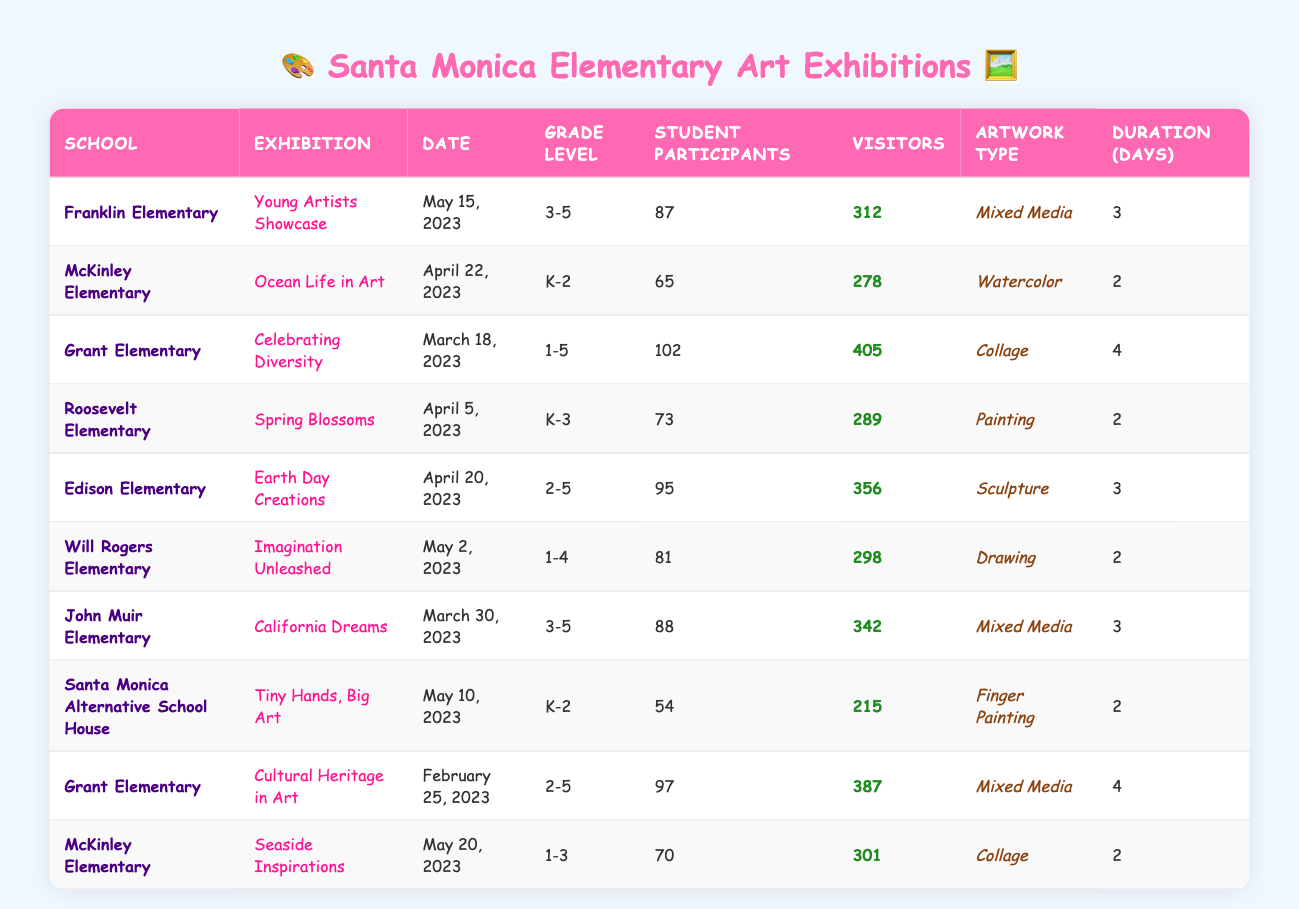What is the highest visitor count for an exhibition? The visitor counts for the exhibitions are: 312, 278, 405, 289, 356, 298, 342, 215, 387, and 301. Among these, 405 is the highest count, which corresponds to the exhibition "Celebrating Diversity" at Grant Elementary.
Answer: 405 Which school had the largest number of student participants? The number of student participants for each school are: Franklin (87), McKinley (65), Grant (102), Roosevelt (73), Edison (95), Will Rogers (81), John Muir (88), Santa Monica Alternative (54), Grant (97), and McKinley (70). The largest number is 102 from Grant Elementary during the "Celebrating Diversity" exhibition.
Answer: Grant Elementary Are there any exhibitions that lasted for more than 3 days? The duration of each exhibition is as follows: 3, 2, 4, 2, 3, 2, 3, 2, 4, and 2 days. The exhibitions with durations exceeding 3 days are "Celebrating Diversity" (4 days) and "Cultural Heritage in Art" (4 days) held at Grant Elementary.
Answer: Yes What is the average number of visitor counts across all exhibitions? The visitor counts sum up to 312 + 278 + 405 + 289 + 356 + 298 + 342 + 215 + 387 + 301 = 3583. There are 10 exhibitions, so the average visitor count is 3583 / 10 = 358.3.
Answer: 358.3 Which type of artwork had the most student participants? The artwork types and their student participants are: Mixed Media (87 + 88), Watercolor (65), Collage (102 + 70), Painting (73), Sculpture (95), and Drawing (81). Adding up the participants for Mixed Media gives 175, Collage gives 172, and others are lower. Thus, Mixed Media has the most participants.
Answer: Mixed Media Did "Tiny Hands, Big Art" have more visitors than "Ocean Life in Art"? The visitor count for "Tiny Hands, Big Art" is 215, and for "Ocean Life in Art," it is 278. Comparing these values shows that 215 is less than 278.
Answer: No What percentage of students participated from Roosevelt Elementary compared to the total participants? The total number of participants is 87 + 65 + 102 + 73 + 95 + 81 + 88 + 54 + 97 + 70 =  975. Roosevelt's participants were 73, therefore, the percentage is (73 / 975) * 100 = 7.48%.
Answer: 7.48% Which exhibition had the lowest visitor count? The visitor counts for the exhibitions are: 312, 278, 405, 289, 356, 298, 342, 215, 387, and 301. The lowest count is 215 for the exhibition "Tiny Hands, Big Art" at Santa Monica Alternative School House.
Answer: Tiny Hands, Big Art How many more visitors did "Earth Day Creations" have compared to "Imagination Unleashed"? The visitor count for "Earth Day Creations" is 356, and for "Imagination Unleashed," it is 298. Subtracting gives 356 - 298 = 58.
Answer: 58 